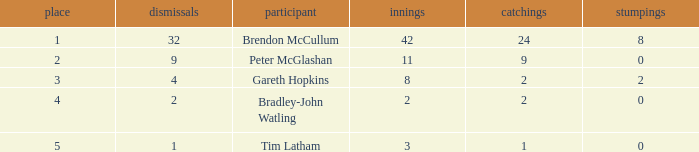How many innings had a total of 2 catches and 0 stumpings? 1.0. 